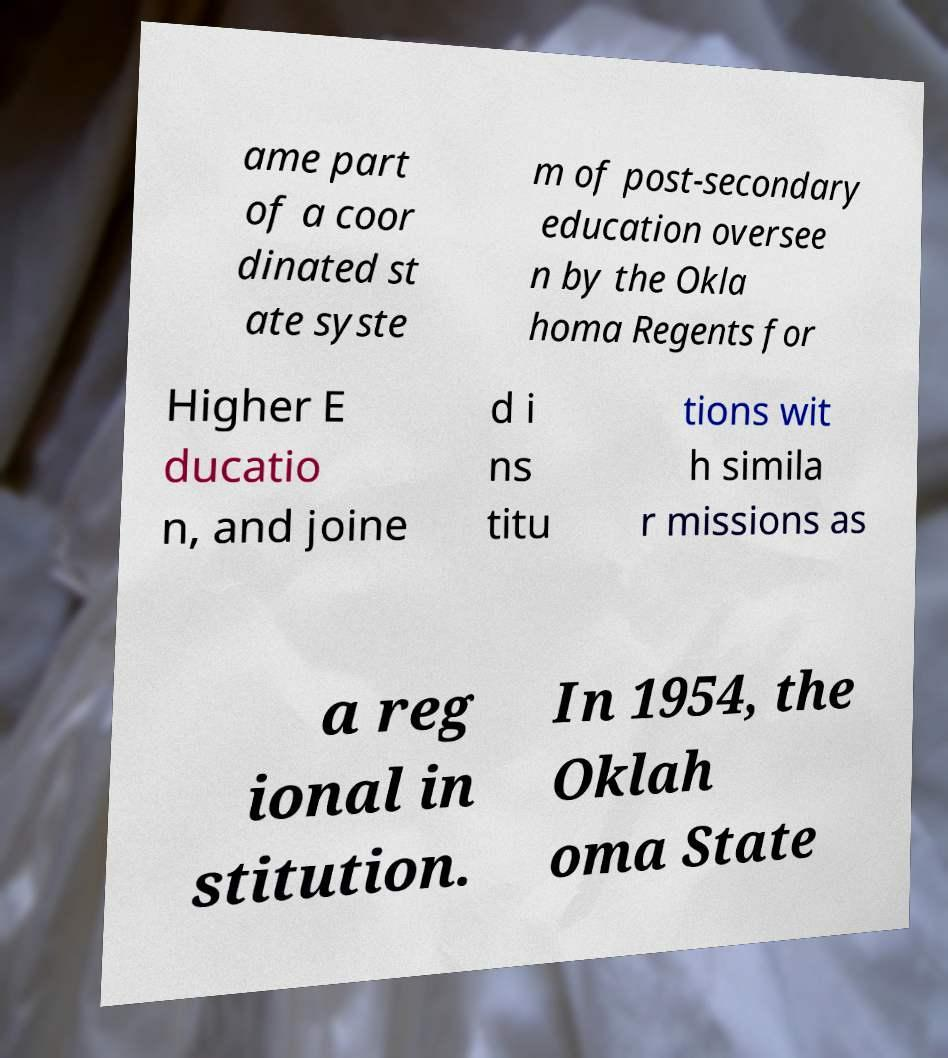For documentation purposes, I need the text within this image transcribed. Could you provide that? ame part of a coor dinated st ate syste m of post-secondary education oversee n by the Okla homa Regents for Higher E ducatio n, and joine d i ns titu tions wit h simila r missions as a reg ional in stitution. In 1954, the Oklah oma State 